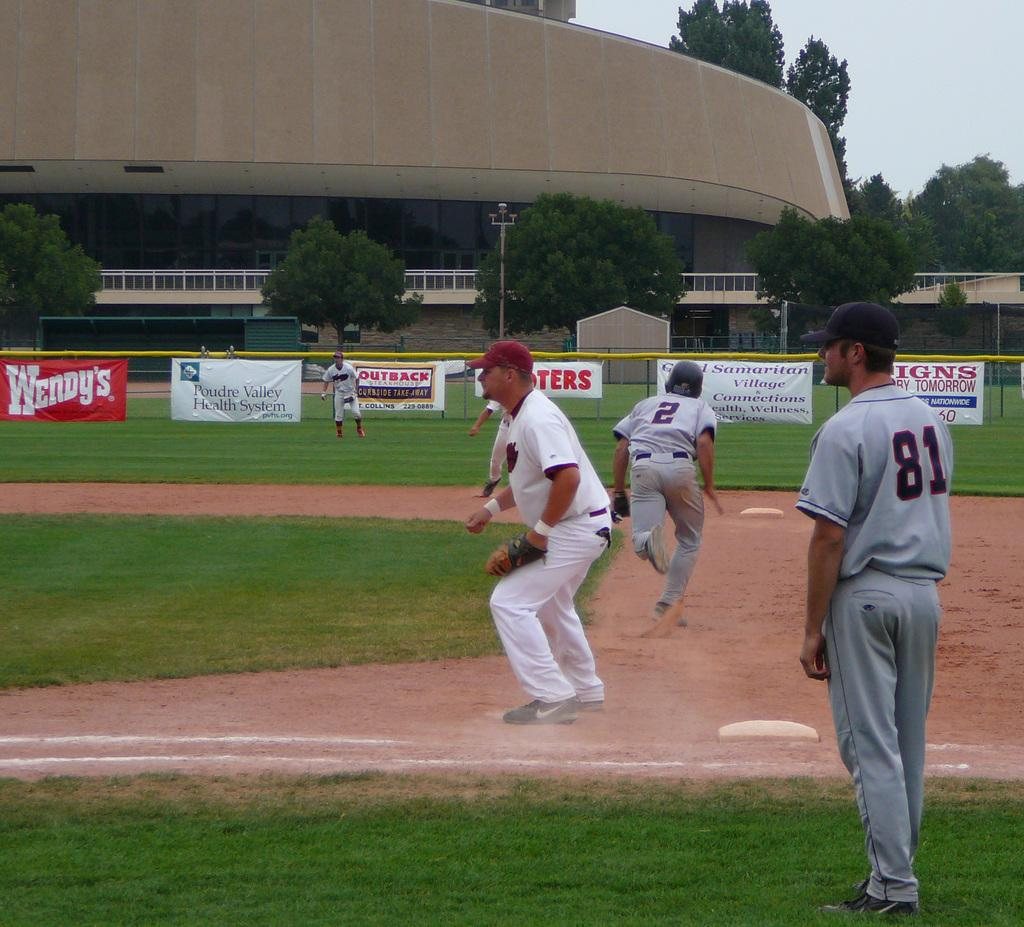<image>
Create a compact narrative representing the image presented. Player number 2 runs from first to second base in an attempt to steal a base. 